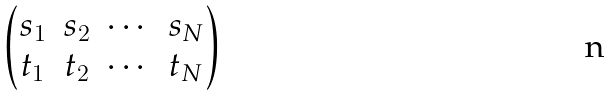<formula> <loc_0><loc_0><loc_500><loc_500>\begin{pmatrix} s _ { 1 } & s _ { 2 } & \cdots & s _ { N } \\ t _ { 1 } & t _ { 2 } & \cdots & t _ { N } \end{pmatrix}</formula> 